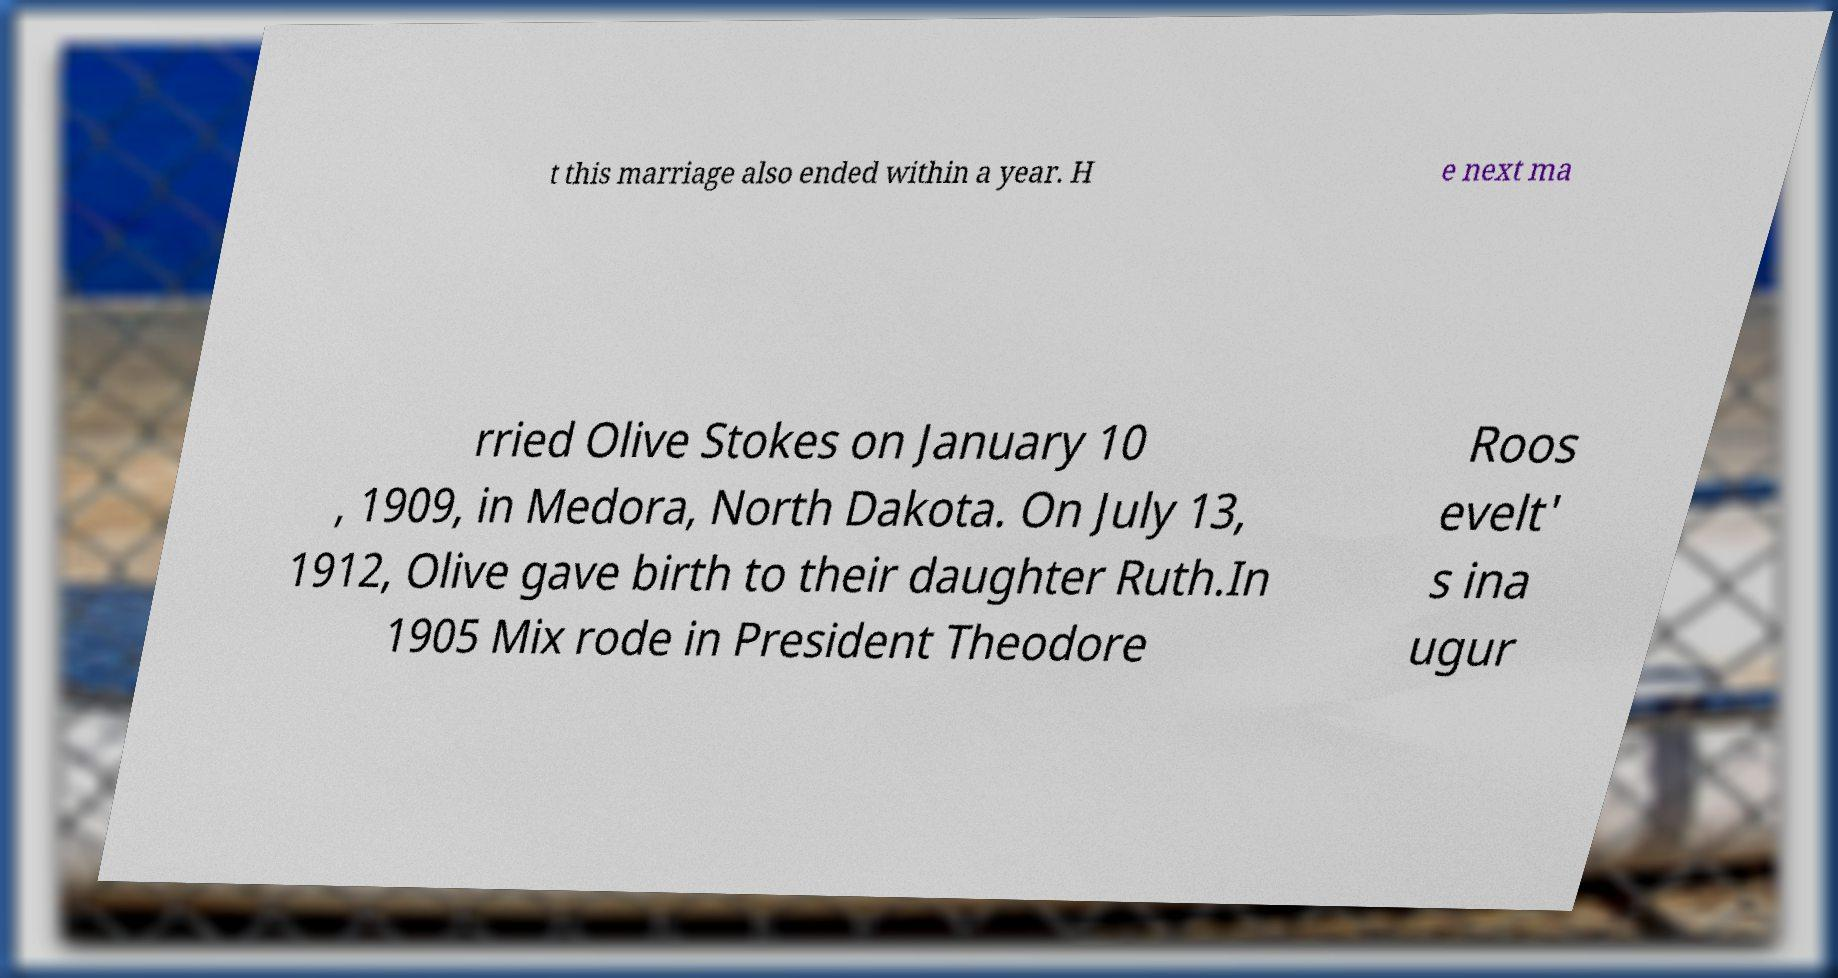Please identify and transcribe the text found in this image. t this marriage also ended within a year. H e next ma rried Olive Stokes on January 10 , 1909, in Medora, North Dakota. On July 13, 1912, Olive gave birth to their daughter Ruth.In 1905 Mix rode in President Theodore Roos evelt' s ina ugur 